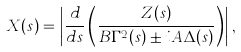<formula> <loc_0><loc_0><loc_500><loc_500>X ( s ) = \left | \frac { d } { d s } \left ( \frac { Z ( s ) } { B \Gamma ^ { 2 } ( s ) \pm i A \Delta ( s ) } \right ) \right | , \\</formula> 